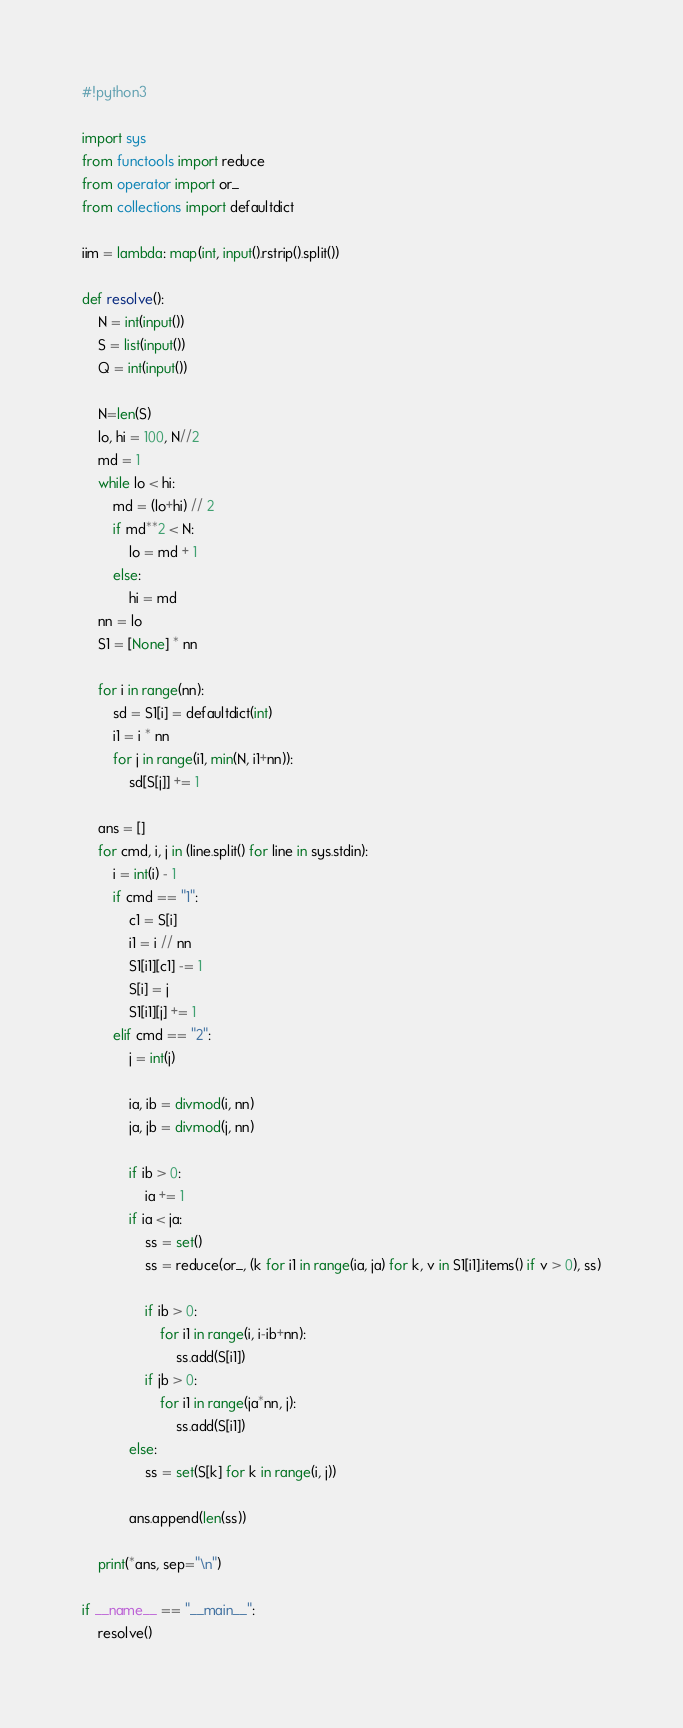<code> <loc_0><loc_0><loc_500><loc_500><_Python_>#!python3

import sys
from functools import reduce
from operator import or_
from collections import defaultdict

iim = lambda: map(int, input().rstrip().split())

def resolve():
    N = int(input())
    S = list(input())
    Q = int(input())

    N=len(S)
    lo, hi = 100, N//2
    md = 1
    while lo < hi:
        md = (lo+hi) // 2
        if md**2 < N:
            lo = md + 1
        else:
            hi = md
    nn = lo
    S1 = [None] * nn

    for i in range(nn):
        sd = S1[i] = defaultdict(int)
        i1 = i * nn
        for j in range(i1, min(N, i1+nn)):
            sd[S[j]] += 1

    ans = []
    for cmd, i, j in (line.split() for line in sys.stdin):
        i = int(i) - 1
        if cmd == "1":
            c1 = S[i]
            i1 = i // nn
            S1[i1][c1] -= 1
            S[i] = j
            S1[i1][j] += 1
        elif cmd == "2":
            j = int(j)

            ia, ib = divmod(i, nn)
            ja, jb = divmod(j, nn)

            if ib > 0:
                ia += 1
            if ia < ja:
                ss = set()
                ss = reduce(or_, (k for i1 in range(ia, ja) for k, v in S1[i1].items() if v > 0), ss)

                if ib > 0:
                    for i1 in range(i, i-ib+nn):
                        ss.add(S[i1])
                if jb > 0:
                    for i1 in range(ja*nn, j):
                        ss.add(S[i1])
            else:
                ss = set(S[k] for k in range(i, j))

            ans.append(len(ss))

    print(*ans, sep="\n")

if __name__ == "__main__":
    resolve()
</code> 